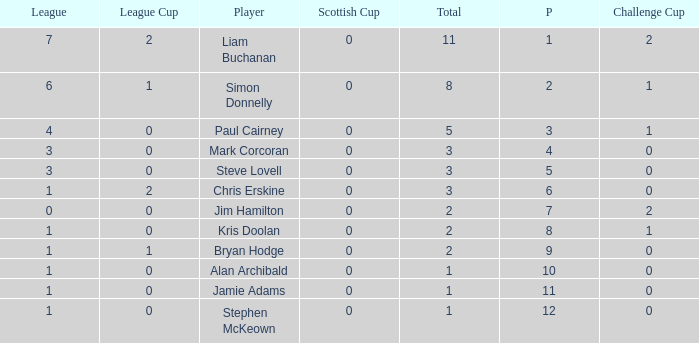What is bryan hodge's player number 1.0. 